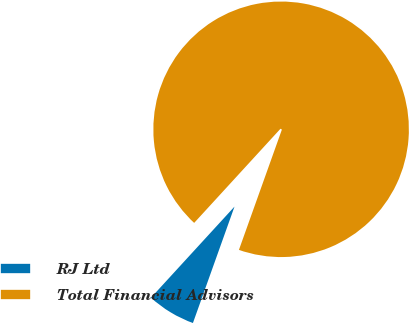Convert chart. <chart><loc_0><loc_0><loc_500><loc_500><pie_chart><fcel>RJ Ltd<fcel>Total Financial Advisors<nl><fcel>6.35%<fcel>93.65%<nl></chart> 